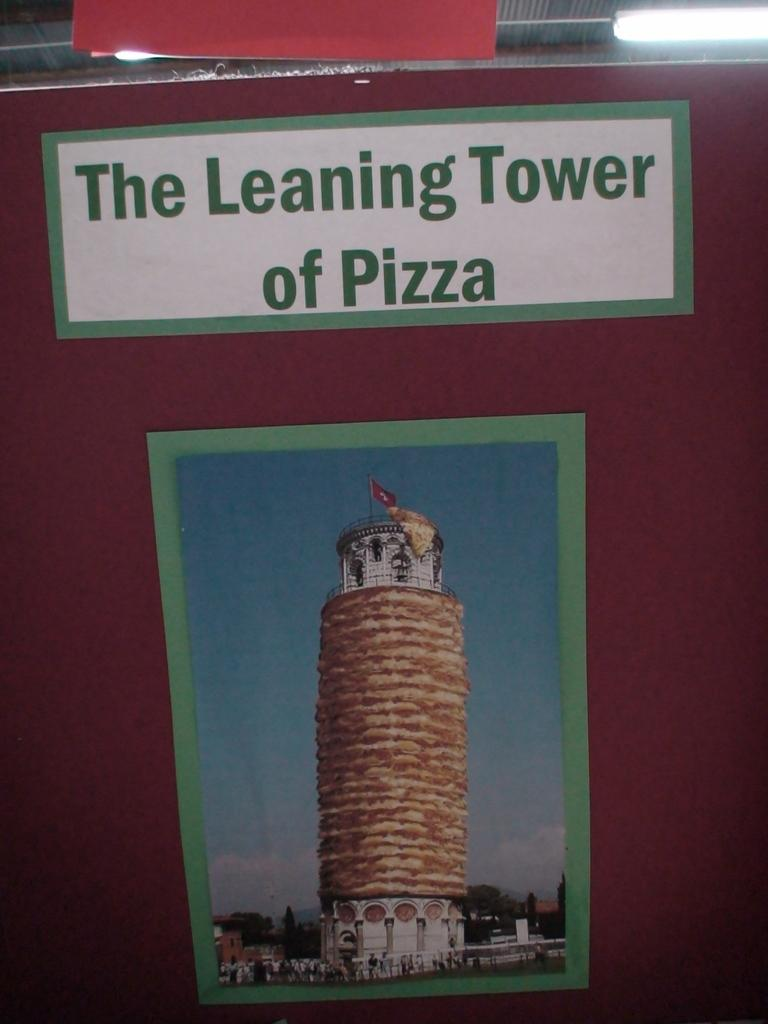<image>
Present a compact description of the photo's key features. A poster shows "The Leaning Tower of Pizza" 